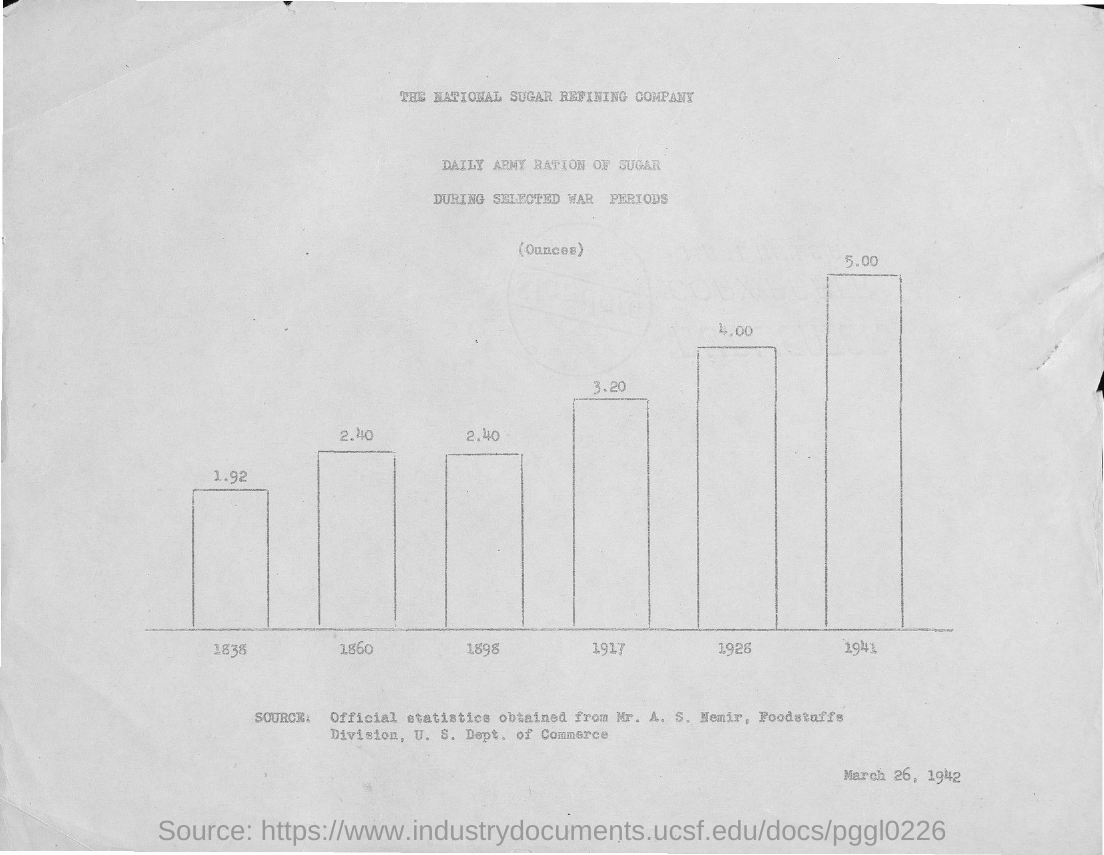List a handful of essential elements in this visual. The daily army ration was higher in 1941 than in any other year. The National Sugar Refining Company is the first title in the document. The daily army ration in the year 1838 was 1.92. The daily army ration was lower in the year 1838. The document mentions that the date is March 26, 1942. 